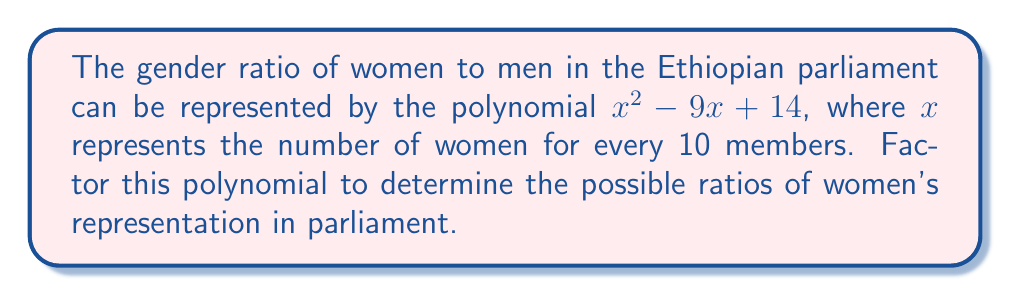Show me your answer to this math problem. To factor this quadratic polynomial, we'll use the following steps:

1) The polynomial is in the form $ax^2 + bx + c$, where $a=1$, $b=-9$, and $c=14$.

2) We need to find two numbers that multiply to give $ac = 1 \times 14 = 14$ and add up to $b = -9$.

3) These numbers are $-7$ and $-2$, as $(-7)(-2) = 14$ and $(-7) + (-2) = -9$.

4) We can rewrite the middle term using these numbers:
   $x^2 - 9x + 14 = x^2 - 7x - 2x + 14$

5) Now we can factor by grouping:
   $(x^2 - 7x) + (-2x + 14)$
   $x(x - 7) - 2(x - 7)$
   $(x - 7)(x - 2)$

This factorization reveals that the possible ratios of women's representation are 7 out of 10 and 2 out of 10 members of parliament.

In the context of advocating for gender equality, this result shows that the current representation could be either quite high (70%) or quite low (20%), highlighting the potential disparity and the need for continued efforts towards equal representation.
Answer: $(x - 7)(x - 2)$ 